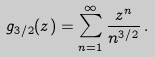Convert formula to latex. <formula><loc_0><loc_0><loc_500><loc_500>g _ { 3 / 2 } ( z ) = \sum _ { n = 1 } ^ { \infty } \frac { z ^ { n } } { n ^ { 3 / 2 } } \, .</formula> 